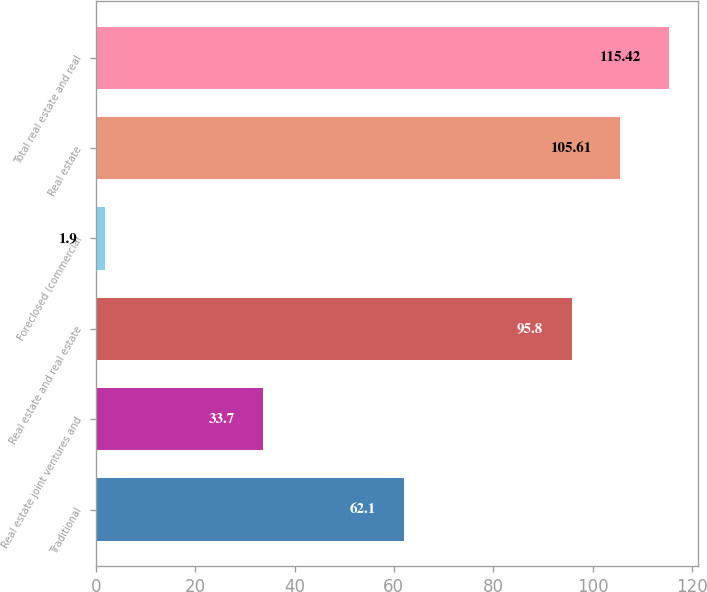Convert chart to OTSL. <chart><loc_0><loc_0><loc_500><loc_500><bar_chart><fcel>Traditional<fcel>Real estate joint ventures and<fcel>Real estate and real estate<fcel>Foreclosed (commercial<fcel>Real estate<fcel>Total real estate and real<nl><fcel>62.1<fcel>33.7<fcel>95.8<fcel>1.9<fcel>105.61<fcel>115.42<nl></chart> 